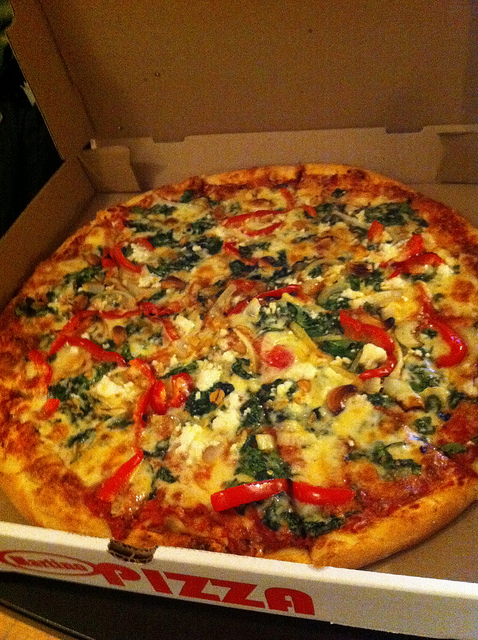<image>These pizzas appear to have come from which pizzeria? I am not sure which pizzeria these pizzas came from. It could be "boston's", "leo's", "wortham", 'sarpinos', 'bardano', "martha's", or 'little neros'. These pizzas appear to have come from which pizzeria? It is ambiguous from which pizzeria these pizzas appear to have come. It could be from "Boston's", "Leo's", "Wortham", "Sarpinos", "Bardano", "Martha's" or "Little Neros". 